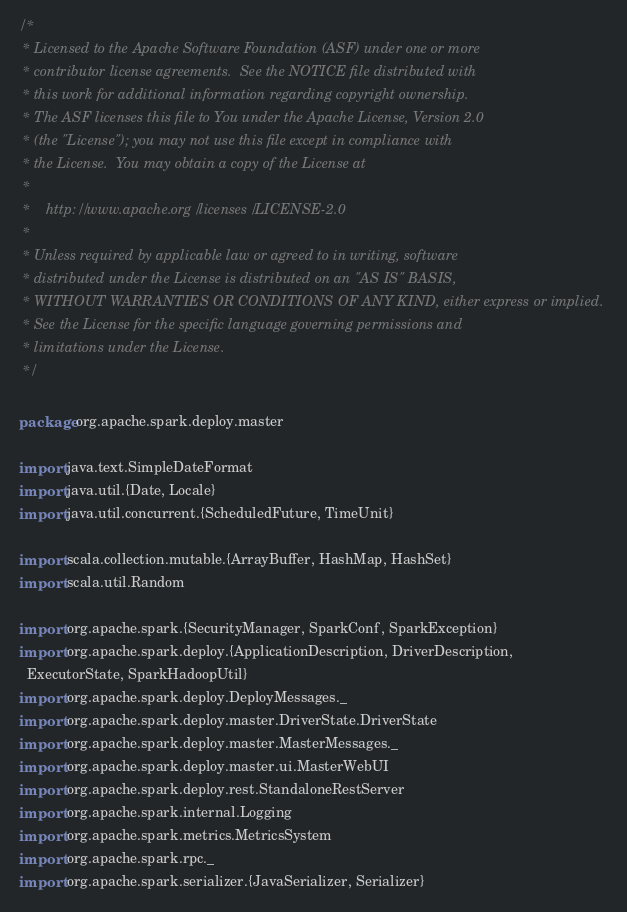Convert code to text. <code><loc_0><loc_0><loc_500><loc_500><_Scala_>/*
 * Licensed to the Apache Software Foundation (ASF) under one or more
 * contributor license agreements.  See the NOTICE file distributed with
 * this work for additional information regarding copyright ownership.
 * The ASF licenses this file to You under the Apache License, Version 2.0
 * (the "License"); you may not use this file except in compliance with
 * the License.  You may obtain a copy of the License at
 *
 *    http://www.apache.org/licenses/LICENSE-2.0
 *
 * Unless required by applicable law or agreed to in writing, software
 * distributed under the License is distributed on an "AS IS" BASIS,
 * WITHOUT WARRANTIES OR CONDITIONS OF ANY KIND, either express or implied.
 * See the License for the specific language governing permissions and
 * limitations under the License.
 */

package org.apache.spark.deploy.master

import java.text.SimpleDateFormat
import java.util.{Date, Locale}
import java.util.concurrent.{ScheduledFuture, TimeUnit}

import scala.collection.mutable.{ArrayBuffer, HashMap, HashSet}
import scala.util.Random

import org.apache.spark.{SecurityManager, SparkConf, SparkException}
import org.apache.spark.deploy.{ApplicationDescription, DriverDescription,
  ExecutorState, SparkHadoopUtil}
import org.apache.spark.deploy.DeployMessages._
import org.apache.spark.deploy.master.DriverState.DriverState
import org.apache.spark.deploy.master.MasterMessages._
import org.apache.spark.deploy.master.ui.MasterWebUI
import org.apache.spark.deploy.rest.StandaloneRestServer
import org.apache.spark.internal.Logging
import org.apache.spark.metrics.MetricsSystem
import org.apache.spark.rpc._
import org.apache.spark.serializer.{JavaSerializer, Serializer}</code> 